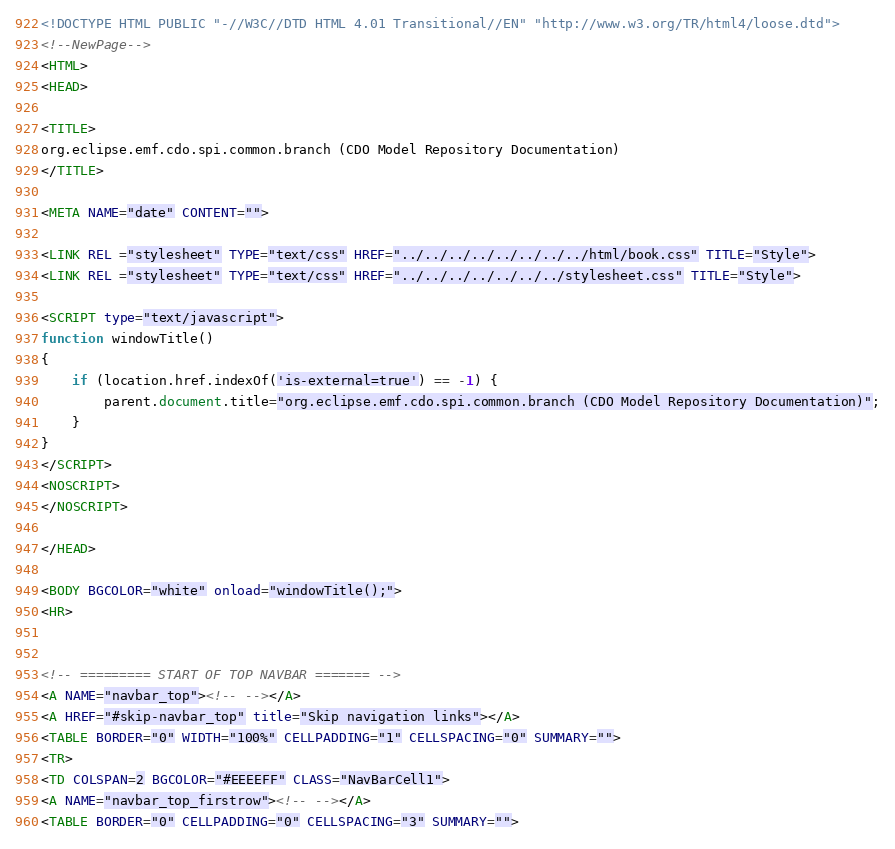<code> <loc_0><loc_0><loc_500><loc_500><_HTML_><!DOCTYPE HTML PUBLIC "-//W3C//DTD HTML 4.01 Transitional//EN" "http://www.w3.org/TR/html4/loose.dtd">
<!--NewPage-->
<HTML>
<HEAD>

<TITLE>
org.eclipse.emf.cdo.spi.common.branch (CDO Model Repository Documentation)
</TITLE>

<META NAME="date" CONTENT="">

<LINK REL ="stylesheet" TYPE="text/css" HREF="../../../../../../../../html/book.css" TITLE="Style">
<LINK REL ="stylesheet" TYPE="text/css" HREF="../../../../../../../stylesheet.css" TITLE="Style">

<SCRIPT type="text/javascript">
function windowTitle()
{
    if (location.href.indexOf('is-external=true') == -1) {
        parent.document.title="org.eclipse.emf.cdo.spi.common.branch (CDO Model Repository Documentation)";
    }
}
</SCRIPT>
<NOSCRIPT>
</NOSCRIPT>

</HEAD>

<BODY BGCOLOR="white" onload="windowTitle();">
<HR>


<!-- ========= START OF TOP NAVBAR ======= -->
<A NAME="navbar_top"><!-- --></A>
<A HREF="#skip-navbar_top" title="Skip navigation links"></A>
<TABLE BORDER="0" WIDTH="100%" CELLPADDING="1" CELLSPACING="0" SUMMARY="">
<TR>
<TD COLSPAN=2 BGCOLOR="#EEEEFF" CLASS="NavBarCell1">
<A NAME="navbar_top_firstrow"><!-- --></A>
<TABLE BORDER="0" CELLPADDING="0" CELLSPACING="3" SUMMARY=""></code> 